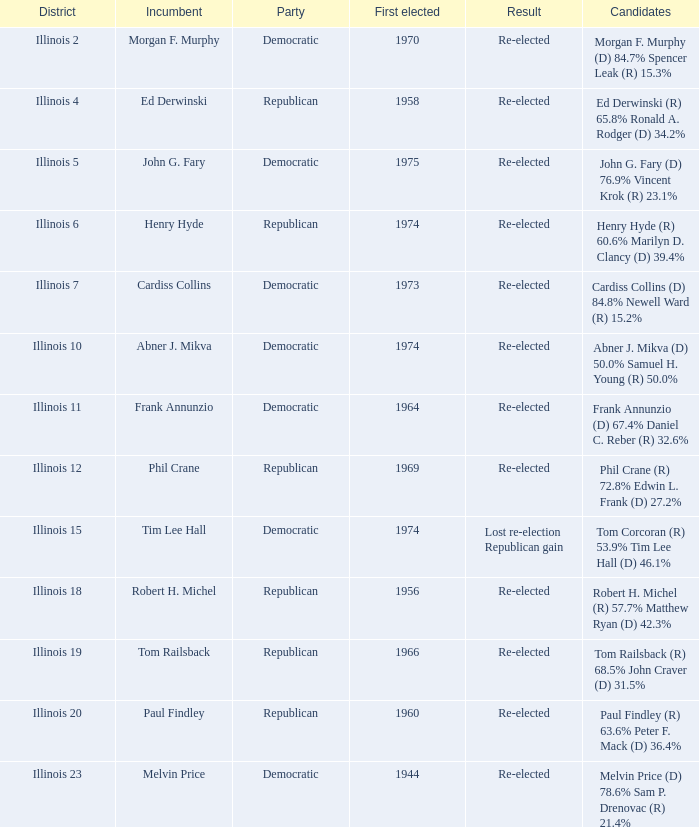Identify the event for tim lee hall. Democratic. 